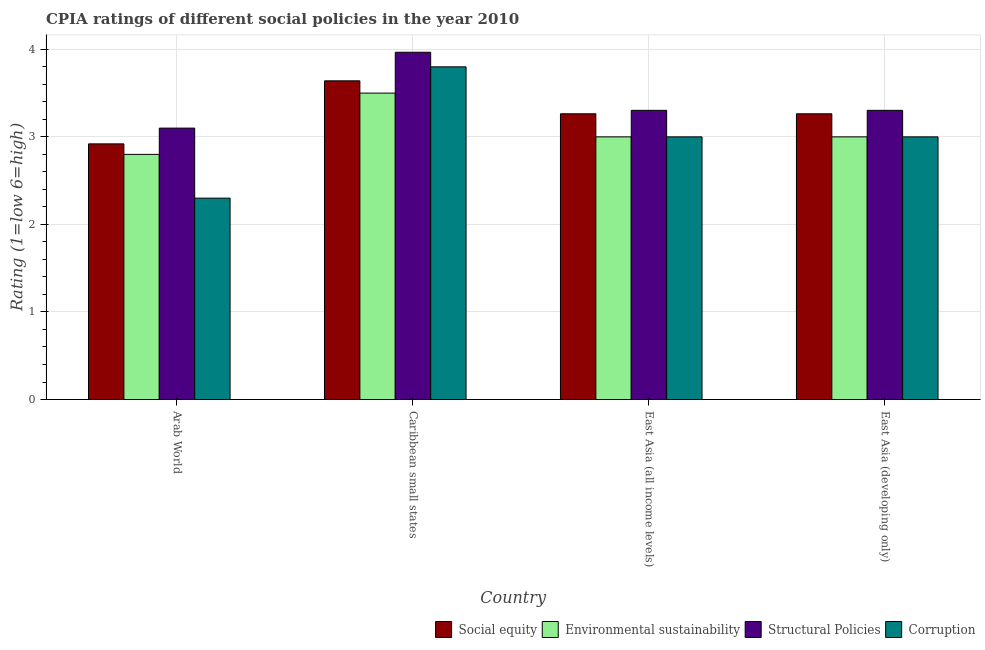Are the number of bars on each tick of the X-axis equal?
Your answer should be very brief. Yes. What is the label of the 2nd group of bars from the left?
Your answer should be very brief. Caribbean small states. In how many cases, is the number of bars for a given country not equal to the number of legend labels?
Offer a very short reply. 0. What is the cpia rating of corruption in East Asia (developing only)?
Provide a succinct answer. 3. Across all countries, what is the maximum cpia rating of structural policies?
Your answer should be compact. 3.97. In which country was the cpia rating of social equity maximum?
Offer a very short reply. Caribbean small states. In which country was the cpia rating of social equity minimum?
Provide a short and direct response. Arab World. What is the difference between the cpia rating of corruption in East Asia (all income levels) and that in East Asia (developing only)?
Your answer should be compact. 0. What is the difference between the cpia rating of social equity in East Asia (developing only) and the cpia rating of structural policies in East Asia (all income levels)?
Your response must be concise. -0.04. What is the average cpia rating of structural policies per country?
Make the answer very short. 3.42. What is the difference between the cpia rating of social equity and cpia rating of environmental sustainability in East Asia (all income levels)?
Provide a succinct answer. 0.26. Is the cpia rating of corruption in Caribbean small states less than that in East Asia (all income levels)?
Provide a succinct answer. No. What is the difference between the highest and the second highest cpia rating of corruption?
Your answer should be very brief. 0.8. In how many countries, is the cpia rating of social equity greater than the average cpia rating of social equity taken over all countries?
Make the answer very short. 1. Is the sum of the cpia rating of corruption in Arab World and East Asia (developing only) greater than the maximum cpia rating of social equity across all countries?
Give a very brief answer. Yes. Is it the case that in every country, the sum of the cpia rating of social equity and cpia rating of corruption is greater than the sum of cpia rating of structural policies and cpia rating of environmental sustainability?
Offer a very short reply. No. What does the 4th bar from the left in East Asia (developing only) represents?
Your answer should be compact. Corruption. What does the 4th bar from the right in Caribbean small states represents?
Your response must be concise. Social equity. How many bars are there?
Provide a short and direct response. 16. Are all the bars in the graph horizontal?
Ensure brevity in your answer.  No. What is the difference between two consecutive major ticks on the Y-axis?
Make the answer very short. 1. Does the graph contain grids?
Keep it short and to the point. Yes. Where does the legend appear in the graph?
Your answer should be compact. Bottom right. What is the title of the graph?
Your answer should be compact. CPIA ratings of different social policies in the year 2010. Does "Services" appear as one of the legend labels in the graph?
Give a very brief answer. No. What is the label or title of the Y-axis?
Your response must be concise. Rating (1=low 6=high). What is the Rating (1=low 6=high) of Social equity in Arab World?
Your response must be concise. 2.92. What is the Rating (1=low 6=high) of Environmental sustainability in Arab World?
Your response must be concise. 2.8. What is the Rating (1=low 6=high) in Structural Policies in Arab World?
Your answer should be very brief. 3.1. What is the Rating (1=low 6=high) in Corruption in Arab World?
Your answer should be compact. 2.3. What is the Rating (1=low 6=high) of Social equity in Caribbean small states?
Provide a short and direct response. 3.64. What is the Rating (1=low 6=high) of Structural Policies in Caribbean small states?
Give a very brief answer. 3.97. What is the Rating (1=low 6=high) in Corruption in Caribbean small states?
Your answer should be very brief. 3.8. What is the Rating (1=low 6=high) of Social equity in East Asia (all income levels)?
Your answer should be very brief. 3.26. What is the Rating (1=low 6=high) in Environmental sustainability in East Asia (all income levels)?
Give a very brief answer. 3. What is the Rating (1=low 6=high) of Structural Policies in East Asia (all income levels)?
Your answer should be compact. 3.3. What is the Rating (1=low 6=high) of Social equity in East Asia (developing only)?
Make the answer very short. 3.26. What is the Rating (1=low 6=high) in Structural Policies in East Asia (developing only)?
Give a very brief answer. 3.3. Across all countries, what is the maximum Rating (1=low 6=high) of Social equity?
Make the answer very short. 3.64. Across all countries, what is the maximum Rating (1=low 6=high) in Structural Policies?
Your answer should be very brief. 3.97. Across all countries, what is the maximum Rating (1=low 6=high) in Corruption?
Ensure brevity in your answer.  3.8. Across all countries, what is the minimum Rating (1=low 6=high) of Social equity?
Keep it short and to the point. 2.92. What is the total Rating (1=low 6=high) in Social equity in the graph?
Offer a very short reply. 13.09. What is the total Rating (1=low 6=high) of Structural Policies in the graph?
Make the answer very short. 13.67. What is the difference between the Rating (1=low 6=high) of Social equity in Arab World and that in Caribbean small states?
Ensure brevity in your answer.  -0.72. What is the difference between the Rating (1=low 6=high) in Structural Policies in Arab World and that in Caribbean small states?
Give a very brief answer. -0.87. What is the difference between the Rating (1=low 6=high) of Social equity in Arab World and that in East Asia (all income levels)?
Provide a succinct answer. -0.34. What is the difference between the Rating (1=low 6=high) in Structural Policies in Arab World and that in East Asia (all income levels)?
Your answer should be compact. -0.2. What is the difference between the Rating (1=low 6=high) of Corruption in Arab World and that in East Asia (all income levels)?
Keep it short and to the point. -0.7. What is the difference between the Rating (1=low 6=high) of Social equity in Arab World and that in East Asia (developing only)?
Make the answer very short. -0.34. What is the difference between the Rating (1=low 6=high) of Environmental sustainability in Arab World and that in East Asia (developing only)?
Give a very brief answer. -0.2. What is the difference between the Rating (1=low 6=high) of Structural Policies in Arab World and that in East Asia (developing only)?
Your answer should be compact. -0.2. What is the difference between the Rating (1=low 6=high) in Corruption in Arab World and that in East Asia (developing only)?
Keep it short and to the point. -0.7. What is the difference between the Rating (1=low 6=high) of Social equity in Caribbean small states and that in East Asia (all income levels)?
Offer a terse response. 0.38. What is the difference between the Rating (1=low 6=high) of Environmental sustainability in Caribbean small states and that in East Asia (all income levels)?
Offer a very short reply. 0.5. What is the difference between the Rating (1=low 6=high) of Structural Policies in Caribbean small states and that in East Asia (all income levels)?
Make the answer very short. 0.66. What is the difference between the Rating (1=low 6=high) of Corruption in Caribbean small states and that in East Asia (all income levels)?
Provide a short and direct response. 0.8. What is the difference between the Rating (1=low 6=high) of Social equity in Caribbean small states and that in East Asia (developing only)?
Keep it short and to the point. 0.38. What is the difference between the Rating (1=low 6=high) in Environmental sustainability in Caribbean small states and that in East Asia (developing only)?
Provide a succinct answer. 0.5. What is the difference between the Rating (1=low 6=high) of Structural Policies in Caribbean small states and that in East Asia (developing only)?
Offer a terse response. 0.66. What is the difference between the Rating (1=low 6=high) in Corruption in Caribbean small states and that in East Asia (developing only)?
Your response must be concise. 0.8. What is the difference between the Rating (1=low 6=high) of Social equity in Arab World and the Rating (1=low 6=high) of Environmental sustainability in Caribbean small states?
Offer a very short reply. -0.58. What is the difference between the Rating (1=low 6=high) of Social equity in Arab World and the Rating (1=low 6=high) of Structural Policies in Caribbean small states?
Provide a succinct answer. -1.05. What is the difference between the Rating (1=low 6=high) in Social equity in Arab World and the Rating (1=low 6=high) in Corruption in Caribbean small states?
Provide a succinct answer. -0.88. What is the difference between the Rating (1=low 6=high) in Environmental sustainability in Arab World and the Rating (1=low 6=high) in Structural Policies in Caribbean small states?
Provide a short and direct response. -1.17. What is the difference between the Rating (1=low 6=high) in Environmental sustainability in Arab World and the Rating (1=low 6=high) in Corruption in Caribbean small states?
Offer a very short reply. -1. What is the difference between the Rating (1=low 6=high) in Structural Policies in Arab World and the Rating (1=low 6=high) in Corruption in Caribbean small states?
Your answer should be compact. -0.7. What is the difference between the Rating (1=low 6=high) of Social equity in Arab World and the Rating (1=low 6=high) of Environmental sustainability in East Asia (all income levels)?
Your answer should be compact. -0.08. What is the difference between the Rating (1=low 6=high) of Social equity in Arab World and the Rating (1=low 6=high) of Structural Policies in East Asia (all income levels)?
Give a very brief answer. -0.38. What is the difference between the Rating (1=low 6=high) in Social equity in Arab World and the Rating (1=low 6=high) in Corruption in East Asia (all income levels)?
Your response must be concise. -0.08. What is the difference between the Rating (1=low 6=high) of Environmental sustainability in Arab World and the Rating (1=low 6=high) of Structural Policies in East Asia (all income levels)?
Provide a short and direct response. -0.5. What is the difference between the Rating (1=low 6=high) of Environmental sustainability in Arab World and the Rating (1=low 6=high) of Corruption in East Asia (all income levels)?
Provide a succinct answer. -0.2. What is the difference between the Rating (1=low 6=high) in Structural Policies in Arab World and the Rating (1=low 6=high) in Corruption in East Asia (all income levels)?
Offer a terse response. 0.1. What is the difference between the Rating (1=low 6=high) in Social equity in Arab World and the Rating (1=low 6=high) in Environmental sustainability in East Asia (developing only)?
Offer a terse response. -0.08. What is the difference between the Rating (1=low 6=high) in Social equity in Arab World and the Rating (1=low 6=high) in Structural Policies in East Asia (developing only)?
Your answer should be compact. -0.38. What is the difference between the Rating (1=low 6=high) in Social equity in Arab World and the Rating (1=low 6=high) in Corruption in East Asia (developing only)?
Provide a succinct answer. -0.08. What is the difference between the Rating (1=low 6=high) of Environmental sustainability in Arab World and the Rating (1=low 6=high) of Structural Policies in East Asia (developing only)?
Ensure brevity in your answer.  -0.5. What is the difference between the Rating (1=low 6=high) in Environmental sustainability in Arab World and the Rating (1=low 6=high) in Corruption in East Asia (developing only)?
Make the answer very short. -0.2. What is the difference between the Rating (1=low 6=high) in Social equity in Caribbean small states and the Rating (1=low 6=high) in Environmental sustainability in East Asia (all income levels)?
Your response must be concise. 0.64. What is the difference between the Rating (1=low 6=high) of Social equity in Caribbean small states and the Rating (1=low 6=high) of Structural Policies in East Asia (all income levels)?
Give a very brief answer. 0.34. What is the difference between the Rating (1=low 6=high) of Social equity in Caribbean small states and the Rating (1=low 6=high) of Corruption in East Asia (all income levels)?
Give a very brief answer. 0.64. What is the difference between the Rating (1=low 6=high) in Environmental sustainability in Caribbean small states and the Rating (1=low 6=high) in Structural Policies in East Asia (all income levels)?
Provide a succinct answer. 0.2. What is the difference between the Rating (1=low 6=high) of Environmental sustainability in Caribbean small states and the Rating (1=low 6=high) of Corruption in East Asia (all income levels)?
Your response must be concise. 0.5. What is the difference between the Rating (1=low 6=high) in Structural Policies in Caribbean small states and the Rating (1=low 6=high) in Corruption in East Asia (all income levels)?
Offer a very short reply. 0.97. What is the difference between the Rating (1=low 6=high) of Social equity in Caribbean small states and the Rating (1=low 6=high) of Environmental sustainability in East Asia (developing only)?
Make the answer very short. 0.64. What is the difference between the Rating (1=low 6=high) in Social equity in Caribbean small states and the Rating (1=low 6=high) in Structural Policies in East Asia (developing only)?
Your answer should be compact. 0.34. What is the difference between the Rating (1=low 6=high) of Social equity in Caribbean small states and the Rating (1=low 6=high) of Corruption in East Asia (developing only)?
Provide a succinct answer. 0.64. What is the difference between the Rating (1=low 6=high) in Environmental sustainability in Caribbean small states and the Rating (1=low 6=high) in Structural Policies in East Asia (developing only)?
Give a very brief answer. 0.2. What is the difference between the Rating (1=low 6=high) in Structural Policies in Caribbean small states and the Rating (1=low 6=high) in Corruption in East Asia (developing only)?
Offer a very short reply. 0.97. What is the difference between the Rating (1=low 6=high) of Social equity in East Asia (all income levels) and the Rating (1=low 6=high) of Environmental sustainability in East Asia (developing only)?
Make the answer very short. 0.26. What is the difference between the Rating (1=low 6=high) in Social equity in East Asia (all income levels) and the Rating (1=low 6=high) in Structural Policies in East Asia (developing only)?
Give a very brief answer. -0.04. What is the difference between the Rating (1=low 6=high) of Social equity in East Asia (all income levels) and the Rating (1=low 6=high) of Corruption in East Asia (developing only)?
Offer a terse response. 0.26. What is the difference between the Rating (1=low 6=high) in Environmental sustainability in East Asia (all income levels) and the Rating (1=low 6=high) in Structural Policies in East Asia (developing only)?
Your answer should be very brief. -0.3. What is the difference between the Rating (1=low 6=high) in Environmental sustainability in East Asia (all income levels) and the Rating (1=low 6=high) in Corruption in East Asia (developing only)?
Make the answer very short. 0. What is the difference between the Rating (1=low 6=high) in Structural Policies in East Asia (all income levels) and the Rating (1=low 6=high) in Corruption in East Asia (developing only)?
Offer a very short reply. 0.3. What is the average Rating (1=low 6=high) in Social equity per country?
Your answer should be very brief. 3.27. What is the average Rating (1=low 6=high) of Environmental sustainability per country?
Offer a very short reply. 3.08. What is the average Rating (1=low 6=high) of Structural Policies per country?
Your answer should be compact. 3.42. What is the average Rating (1=low 6=high) in Corruption per country?
Offer a very short reply. 3.02. What is the difference between the Rating (1=low 6=high) in Social equity and Rating (1=low 6=high) in Environmental sustainability in Arab World?
Make the answer very short. 0.12. What is the difference between the Rating (1=low 6=high) of Social equity and Rating (1=low 6=high) of Structural Policies in Arab World?
Your response must be concise. -0.18. What is the difference between the Rating (1=low 6=high) in Social equity and Rating (1=low 6=high) in Corruption in Arab World?
Offer a very short reply. 0.62. What is the difference between the Rating (1=low 6=high) in Environmental sustainability and Rating (1=low 6=high) in Structural Policies in Arab World?
Make the answer very short. -0.3. What is the difference between the Rating (1=low 6=high) of Environmental sustainability and Rating (1=low 6=high) of Corruption in Arab World?
Your answer should be compact. 0.5. What is the difference between the Rating (1=low 6=high) of Structural Policies and Rating (1=low 6=high) of Corruption in Arab World?
Provide a succinct answer. 0.8. What is the difference between the Rating (1=low 6=high) of Social equity and Rating (1=low 6=high) of Environmental sustainability in Caribbean small states?
Provide a short and direct response. 0.14. What is the difference between the Rating (1=low 6=high) in Social equity and Rating (1=low 6=high) in Structural Policies in Caribbean small states?
Ensure brevity in your answer.  -0.33. What is the difference between the Rating (1=low 6=high) in Social equity and Rating (1=low 6=high) in Corruption in Caribbean small states?
Your answer should be very brief. -0.16. What is the difference between the Rating (1=low 6=high) of Environmental sustainability and Rating (1=low 6=high) of Structural Policies in Caribbean small states?
Offer a very short reply. -0.47. What is the difference between the Rating (1=low 6=high) of Structural Policies and Rating (1=low 6=high) of Corruption in Caribbean small states?
Your answer should be very brief. 0.17. What is the difference between the Rating (1=low 6=high) of Social equity and Rating (1=low 6=high) of Environmental sustainability in East Asia (all income levels)?
Keep it short and to the point. 0.26. What is the difference between the Rating (1=low 6=high) in Social equity and Rating (1=low 6=high) in Structural Policies in East Asia (all income levels)?
Make the answer very short. -0.04. What is the difference between the Rating (1=low 6=high) of Social equity and Rating (1=low 6=high) of Corruption in East Asia (all income levels)?
Ensure brevity in your answer.  0.26. What is the difference between the Rating (1=low 6=high) of Environmental sustainability and Rating (1=low 6=high) of Structural Policies in East Asia (all income levels)?
Your response must be concise. -0.3. What is the difference between the Rating (1=low 6=high) in Environmental sustainability and Rating (1=low 6=high) in Corruption in East Asia (all income levels)?
Your answer should be compact. 0. What is the difference between the Rating (1=low 6=high) in Structural Policies and Rating (1=low 6=high) in Corruption in East Asia (all income levels)?
Keep it short and to the point. 0.3. What is the difference between the Rating (1=low 6=high) of Social equity and Rating (1=low 6=high) of Environmental sustainability in East Asia (developing only)?
Your answer should be very brief. 0.26. What is the difference between the Rating (1=low 6=high) of Social equity and Rating (1=low 6=high) of Structural Policies in East Asia (developing only)?
Your answer should be very brief. -0.04. What is the difference between the Rating (1=low 6=high) in Social equity and Rating (1=low 6=high) in Corruption in East Asia (developing only)?
Your answer should be very brief. 0.26. What is the difference between the Rating (1=low 6=high) in Environmental sustainability and Rating (1=low 6=high) in Structural Policies in East Asia (developing only)?
Keep it short and to the point. -0.3. What is the difference between the Rating (1=low 6=high) of Structural Policies and Rating (1=low 6=high) of Corruption in East Asia (developing only)?
Make the answer very short. 0.3. What is the ratio of the Rating (1=low 6=high) in Social equity in Arab World to that in Caribbean small states?
Give a very brief answer. 0.8. What is the ratio of the Rating (1=low 6=high) in Environmental sustainability in Arab World to that in Caribbean small states?
Your answer should be compact. 0.8. What is the ratio of the Rating (1=low 6=high) of Structural Policies in Arab World to that in Caribbean small states?
Offer a very short reply. 0.78. What is the ratio of the Rating (1=low 6=high) of Corruption in Arab World to that in Caribbean small states?
Your response must be concise. 0.61. What is the ratio of the Rating (1=low 6=high) of Social equity in Arab World to that in East Asia (all income levels)?
Make the answer very short. 0.89. What is the ratio of the Rating (1=low 6=high) in Environmental sustainability in Arab World to that in East Asia (all income levels)?
Provide a short and direct response. 0.93. What is the ratio of the Rating (1=low 6=high) of Structural Policies in Arab World to that in East Asia (all income levels)?
Make the answer very short. 0.94. What is the ratio of the Rating (1=low 6=high) in Corruption in Arab World to that in East Asia (all income levels)?
Keep it short and to the point. 0.77. What is the ratio of the Rating (1=low 6=high) in Social equity in Arab World to that in East Asia (developing only)?
Make the answer very short. 0.89. What is the ratio of the Rating (1=low 6=high) of Structural Policies in Arab World to that in East Asia (developing only)?
Ensure brevity in your answer.  0.94. What is the ratio of the Rating (1=low 6=high) in Corruption in Arab World to that in East Asia (developing only)?
Your answer should be very brief. 0.77. What is the ratio of the Rating (1=low 6=high) in Social equity in Caribbean small states to that in East Asia (all income levels)?
Your answer should be compact. 1.12. What is the ratio of the Rating (1=low 6=high) in Structural Policies in Caribbean small states to that in East Asia (all income levels)?
Provide a succinct answer. 1.2. What is the ratio of the Rating (1=low 6=high) in Corruption in Caribbean small states to that in East Asia (all income levels)?
Offer a very short reply. 1.27. What is the ratio of the Rating (1=low 6=high) of Social equity in Caribbean small states to that in East Asia (developing only)?
Provide a short and direct response. 1.12. What is the ratio of the Rating (1=low 6=high) in Environmental sustainability in Caribbean small states to that in East Asia (developing only)?
Offer a very short reply. 1.17. What is the ratio of the Rating (1=low 6=high) of Structural Policies in Caribbean small states to that in East Asia (developing only)?
Offer a terse response. 1.2. What is the ratio of the Rating (1=low 6=high) of Corruption in Caribbean small states to that in East Asia (developing only)?
Offer a very short reply. 1.27. What is the ratio of the Rating (1=low 6=high) in Social equity in East Asia (all income levels) to that in East Asia (developing only)?
Your answer should be compact. 1. What is the ratio of the Rating (1=low 6=high) of Environmental sustainability in East Asia (all income levels) to that in East Asia (developing only)?
Your response must be concise. 1. What is the ratio of the Rating (1=low 6=high) in Corruption in East Asia (all income levels) to that in East Asia (developing only)?
Provide a succinct answer. 1. What is the difference between the highest and the second highest Rating (1=low 6=high) in Social equity?
Offer a terse response. 0.38. What is the difference between the highest and the second highest Rating (1=low 6=high) in Environmental sustainability?
Your answer should be compact. 0.5. What is the difference between the highest and the second highest Rating (1=low 6=high) of Structural Policies?
Offer a terse response. 0.66. What is the difference between the highest and the second highest Rating (1=low 6=high) in Corruption?
Keep it short and to the point. 0.8. What is the difference between the highest and the lowest Rating (1=low 6=high) in Social equity?
Your answer should be very brief. 0.72. What is the difference between the highest and the lowest Rating (1=low 6=high) in Structural Policies?
Provide a short and direct response. 0.87. 